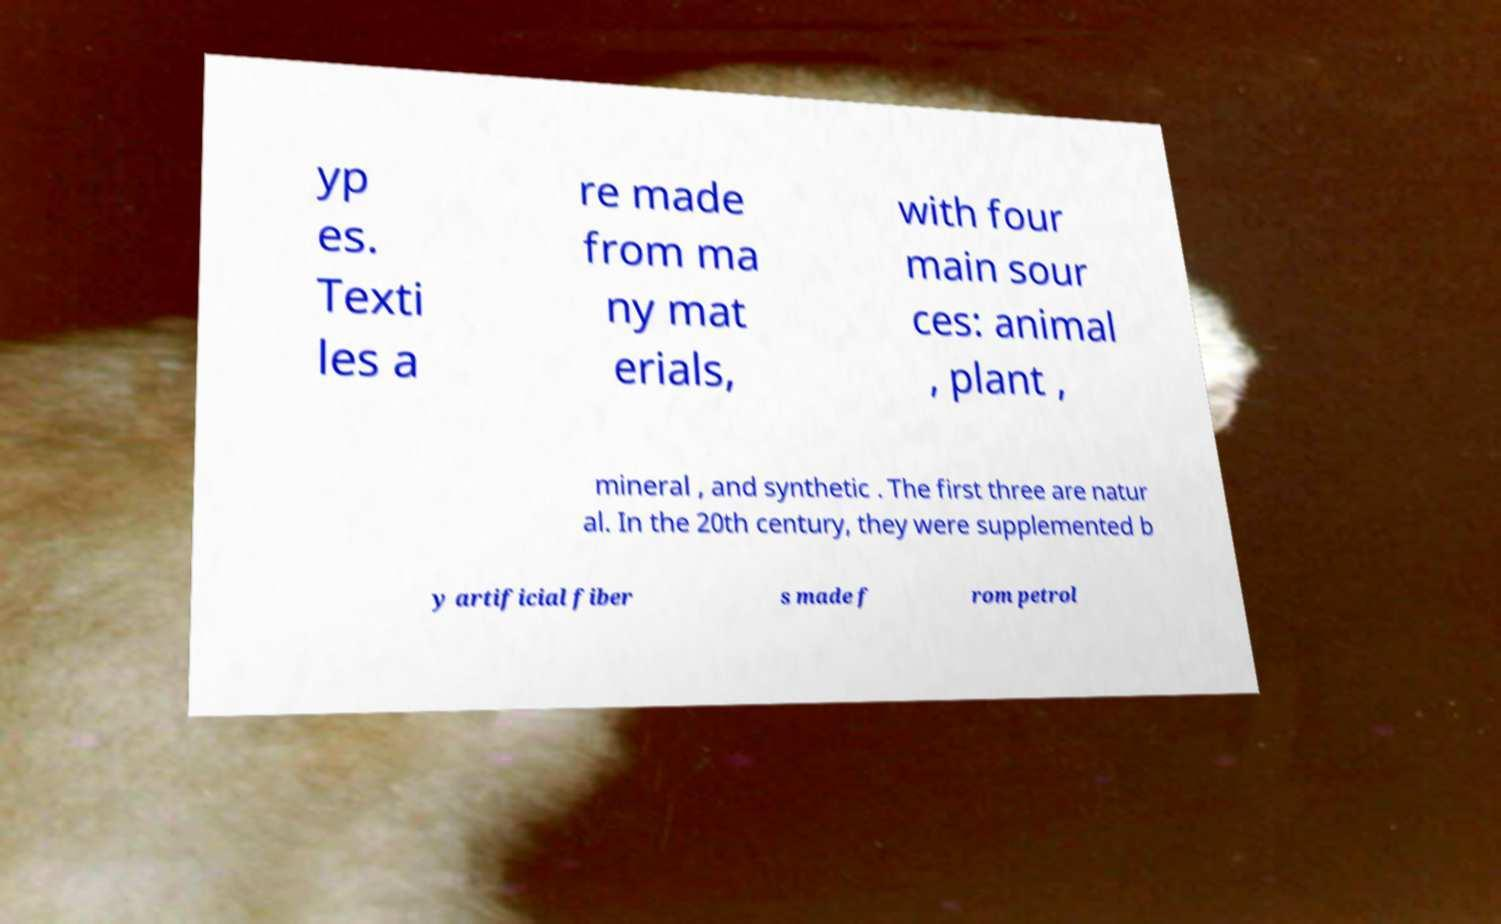Can you read and provide the text displayed in the image?This photo seems to have some interesting text. Can you extract and type it out for me? yp es. Texti les a re made from ma ny mat erials, with four main sour ces: animal , plant , mineral , and synthetic . The first three are natur al. In the 20th century, they were supplemented b y artificial fiber s made f rom petrol 